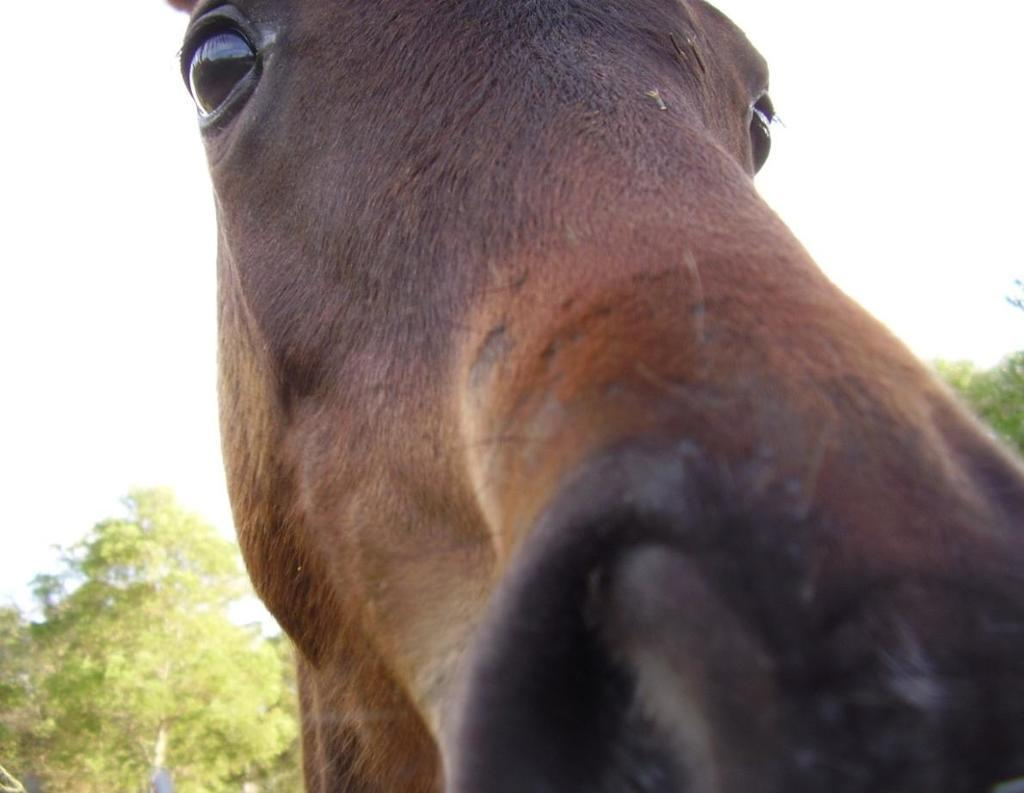What is the main subject in the center of the image? There is an animal in the center of the image. What type of vegetation can be seen at the bottom of the image? There are trees at the bottom of the image. What part of the natural environment is visible in the background of the image? The sky is visible in the background of the image. What type of berry is the animal holding in the image? There is no berry present in the image, and the animal is not holding anything. 